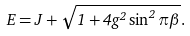<formula> <loc_0><loc_0><loc_500><loc_500>E = J + \sqrt { 1 + 4 g ^ { 2 } \sin ^ { 2 } \pi \beta } .</formula> 